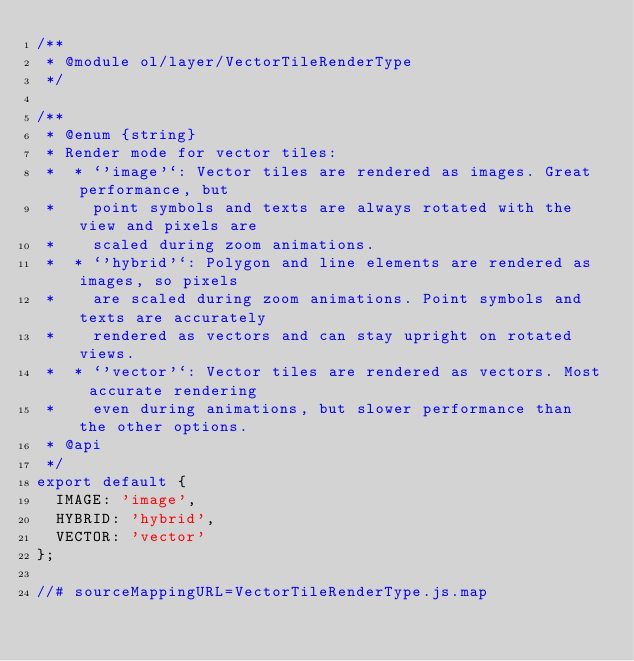<code> <loc_0><loc_0><loc_500><loc_500><_JavaScript_>/**
 * @module ol/layer/VectorTileRenderType
 */

/**
 * @enum {string}
 * Render mode for vector tiles:
 *  * `'image'`: Vector tiles are rendered as images. Great performance, but
 *    point symbols and texts are always rotated with the view and pixels are
 *    scaled during zoom animations.
 *  * `'hybrid'`: Polygon and line elements are rendered as images, so pixels
 *    are scaled during zoom animations. Point symbols and texts are accurately
 *    rendered as vectors and can stay upright on rotated views.
 *  * `'vector'`: Vector tiles are rendered as vectors. Most accurate rendering
 *    even during animations, but slower performance than the other options.
 * @api
 */
export default {
  IMAGE: 'image',
  HYBRID: 'hybrid',
  VECTOR: 'vector'
};

//# sourceMappingURL=VectorTileRenderType.js.map</code> 